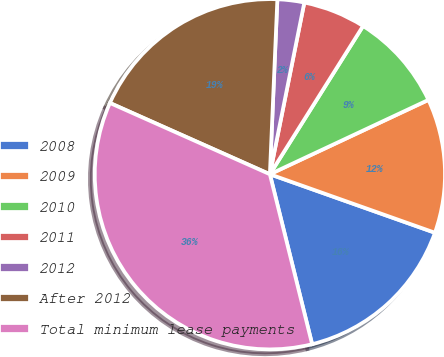Convert chart to OTSL. <chart><loc_0><loc_0><loc_500><loc_500><pie_chart><fcel>2008<fcel>2009<fcel>2010<fcel>2011<fcel>2012<fcel>After 2012<fcel>Total minimum lease payments<nl><fcel>15.7%<fcel>12.4%<fcel>9.09%<fcel>5.78%<fcel>2.47%<fcel>19.01%<fcel>35.55%<nl></chart> 